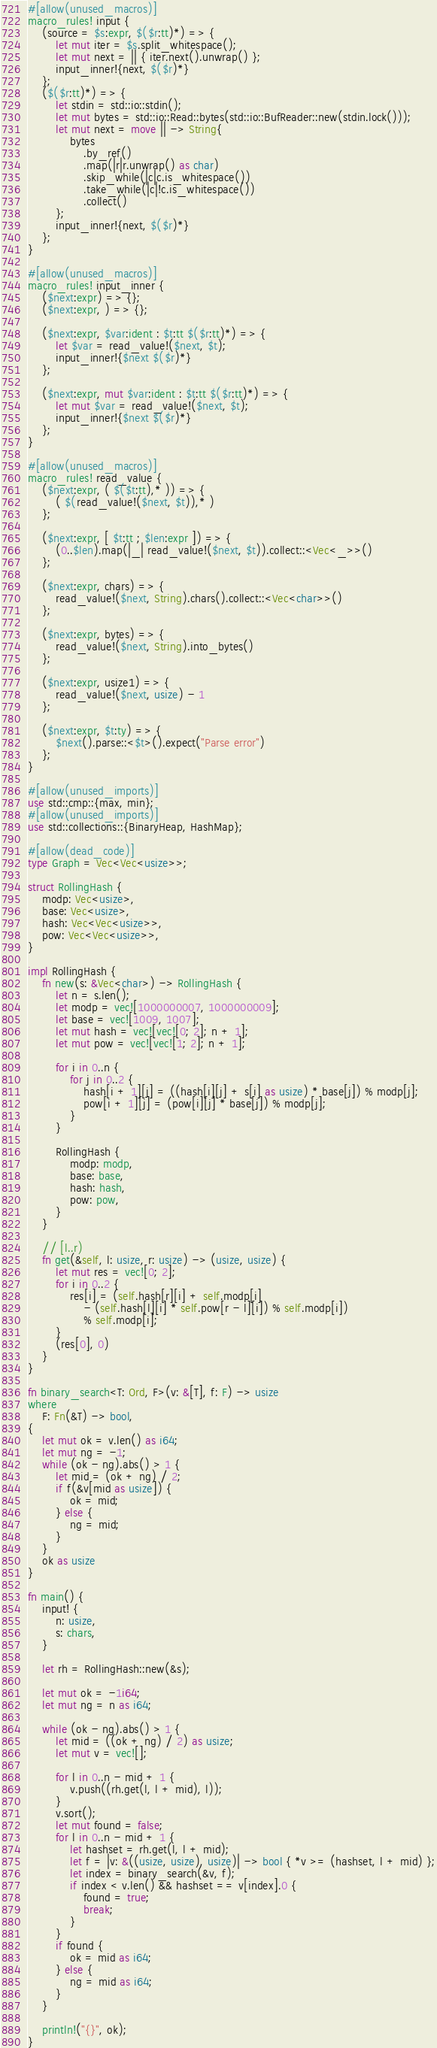<code> <loc_0><loc_0><loc_500><loc_500><_Rust_>#[allow(unused_macros)]
macro_rules! input {
    (source = $s:expr, $($r:tt)*) => {
        let mut iter = $s.split_whitespace();
        let mut next = || { iter.next().unwrap() };
        input_inner!{next, $($r)*}
    };
    ($($r:tt)*) => {
        let stdin = std::io::stdin();
        let mut bytes = std::io::Read::bytes(std::io::BufReader::new(stdin.lock()));
        let mut next = move || -> String{
            bytes
                .by_ref()
                .map(|r|r.unwrap() as char)
                .skip_while(|c|c.is_whitespace())
                .take_while(|c|!c.is_whitespace())
                .collect()
        };
        input_inner!{next, $($r)*}
    };
}

#[allow(unused_macros)]
macro_rules! input_inner {
    ($next:expr) => {};
    ($next:expr, ) => {};

    ($next:expr, $var:ident : $t:tt $($r:tt)*) => {
        let $var = read_value!($next, $t);
        input_inner!{$next $($r)*}
    };

    ($next:expr, mut $var:ident : $t:tt $($r:tt)*) => {
        let mut $var = read_value!($next, $t);
        input_inner!{$next $($r)*}
    };
}

#[allow(unused_macros)]
macro_rules! read_value {
    ($next:expr, ( $($t:tt),* )) => {
        ( $(read_value!($next, $t)),* )
    };

    ($next:expr, [ $t:tt ; $len:expr ]) => {
        (0..$len).map(|_| read_value!($next, $t)).collect::<Vec<_>>()
    };

    ($next:expr, chars) => {
        read_value!($next, String).chars().collect::<Vec<char>>()
    };

    ($next:expr, bytes) => {
        read_value!($next, String).into_bytes()
    };

    ($next:expr, usize1) => {
        read_value!($next, usize) - 1
    };

    ($next:expr, $t:ty) => {
        $next().parse::<$t>().expect("Parse error")
    };
}

#[allow(unused_imports)]
use std::cmp::{max, min};
#[allow(unused_imports)]
use std::collections::{BinaryHeap, HashMap};

#[allow(dead_code)]
type Graph = Vec<Vec<usize>>;

struct RollingHash {
    modp: Vec<usize>,
    base: Vec<usize>,
    hash: Vec<Vec<usize>>,
    pow: Vec<Vec<usize>>,
}

impl RollingHash {
    fn new(s: &Vec<char>) -> RollingHash {
        let n = s.len();
        let modp = vec![1000000007, 1000000009];
        let base = vec![1009, 1007];
        let mut hash = vec![vec![0; 2]; n + 1];
        let mut pow = vec![vec![1; 2]; n + 1];

        for i in 0..n {
            for j in 0..2 {
                hash[i + 1][j] = ((hash[i][j] + s[i] as usize) * base[j]) % modp[j];
                pow[i + 1][j] = (pow[i][j] * base[j]) % modp[j];
            }
        }

        RollingHash {
            modp: modp,
            base: base,
            hash: hash,
            pow: pow,
        }
    }

    // [l..r)
    fn get(&self, l: usize, r: usize) -> (usize, usize) {
        let mut res = vec![0; 2];
        for i in 0..2 {
            res[i] = (self.hash[r][i] + self.modp[i]
                - (self.hash[l][i] * self.pow[r - l][i]) % self.modp[i])
                % self.modp[i];
        }
        (res[0], 0)
    }
}

fn binary_search<T: Ord, F>(v: &[T], f: F) -> usize
where
    F: Fn(&T) -> bool,
{
    let mut ok = v.len() as i64;
    let mut ng = -1;
    while (ok - ng).abs() > 1 {
        let mid = (ok + ng) / 2;
        if f(&v[mid as usize]) {
            ok = mid;
        } else {
            ng = mid;
        }
    }
    ok as usize
}

fn main() {
    input! {
        n: usize,
        s: chars,
    }

    let rh = RollingHash::new(&s);

    let mut ok = -1i64;
    let mut ng = n as i64;

    while (ok - ng).abs() > 1 {
        let mid = ((ok + ng) / 2) as usize;
        let mut v = vec![];

        for l in 0..n - mid + 1 {
            v.push((rh.get(l, l + mid), l));
        }
        v.sort();
        let mut found = false;
        for l in 0..n - mid + 1 {
            let hashset = rh.get(l, l + mid);
            let f = |v: &((usize, usize), usize)| -> bool { *v >= (hashset, l + mid) };
            let index = binary_search(&v, f);
            if index < v.len() && hashset == v[index].0 {
                found = true;
                break;
            }
        }
        if found {
            ok = mid as i64;
        } else {
            ng = mid as i64;
        }
    }

    println!("{}", ok);
}
</code> 